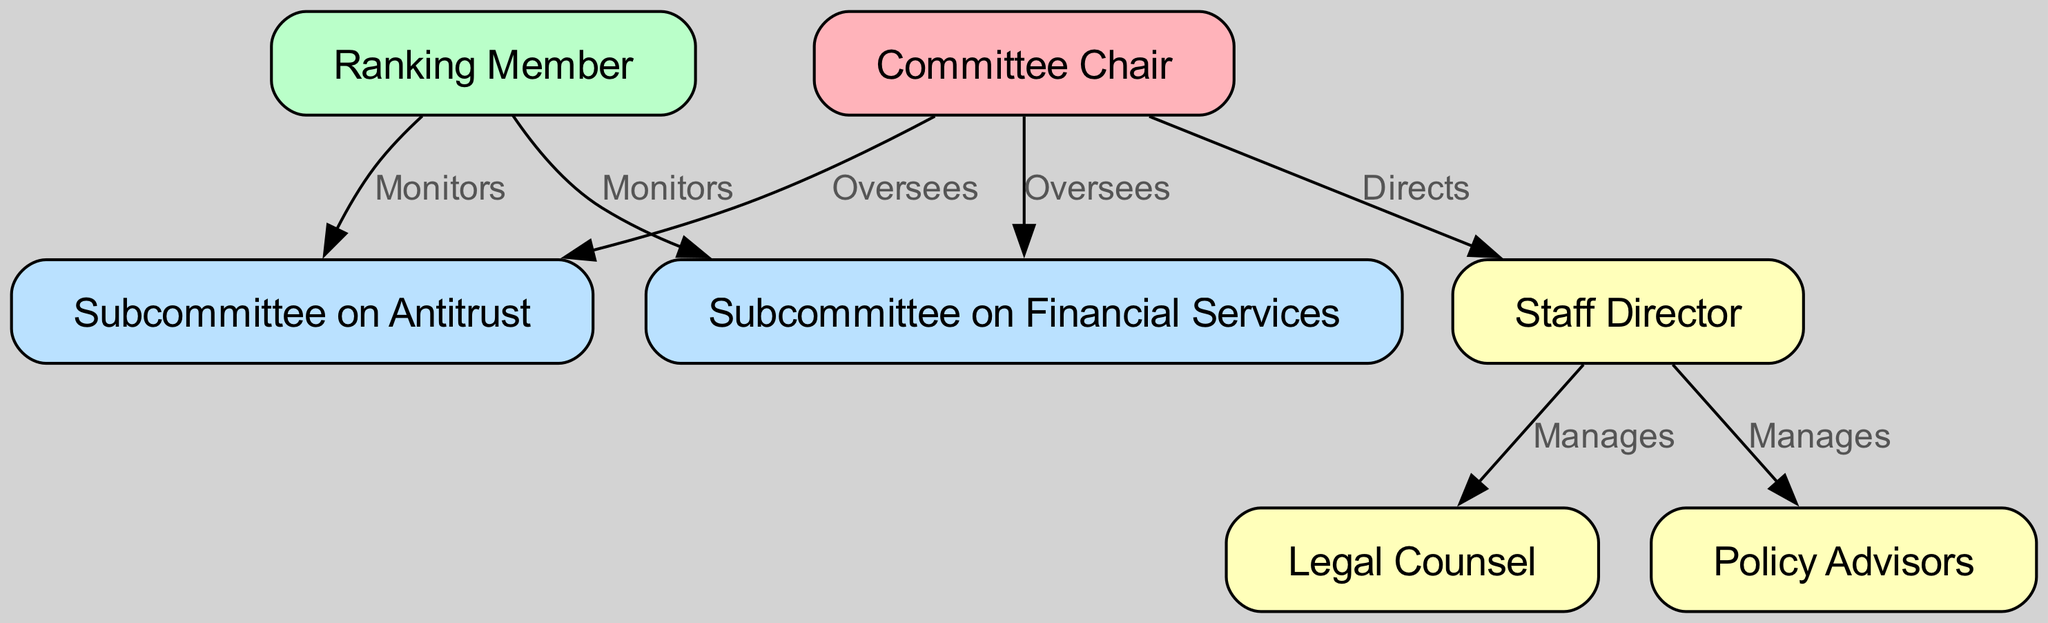What is the role of the 'Committee Chair'? The 'Committee Chair' oversees both the 'Subcommittee on Financial Services' and the 'Subcommittee on Antitrust', which defines their primary role in the committee structure.
Answer: Oversees How many subcommittees are shown in the diagram? There are two subcommittees displayed in the diagram: 'Subcommittee on Financial Services' and 'Subcommittee on Antitrust'. This is determined by counting the nodes labeled as subcommittees.
Answer: Two Who manages the 'Legal Counsel'? The 'Legal Counsel' is managed by the 'Staff Director', as indicated by the directed edge from 'Staff Director' to 'Legal Counsel'.
Answer: Staff Director What relationships exist between the 'Ranking Member' and subcommittees? The 'Ranking Member' monitors both subcommittees, specifically the 'Subcommittee on Financial Services' and the 'Subcommittee on Antitrust', showcasing their supervisory role.
Answer: Monitors Which position has oversight of the 'Staff Director'? The 'Committee Chair' has a direct oversight role over the 'Staff Director', as depicted by the directed edge connecting them.
Answer: Committee Chair What is the function of the 'Policy Advisors'? The 'Policy Advisors' are managed by the 'Staff Director'. This relationship is highlighted by the edge from 'Staff Director' towards 'Policy Advisors'.
Answer: Managed How many total edges are there in the diagram? The diagram contains six edges, which can be counted by identifying all the directed connections between nodes.
Answer: Six Which subcommittee is associated with finance? The subcommittee associated with finance is explicitly labeled as the 'Subcommittee on Financial Services', identifiable by its node label.
Answer: Subcommittee on Financial Services Who are the two main leaders of the committee structure? The two main leaders are the 'Committee Chair' and the 'Ranking Member', who are positioned at the top of the organizational structure.
Answer: Committee Chair and Ranking Member 